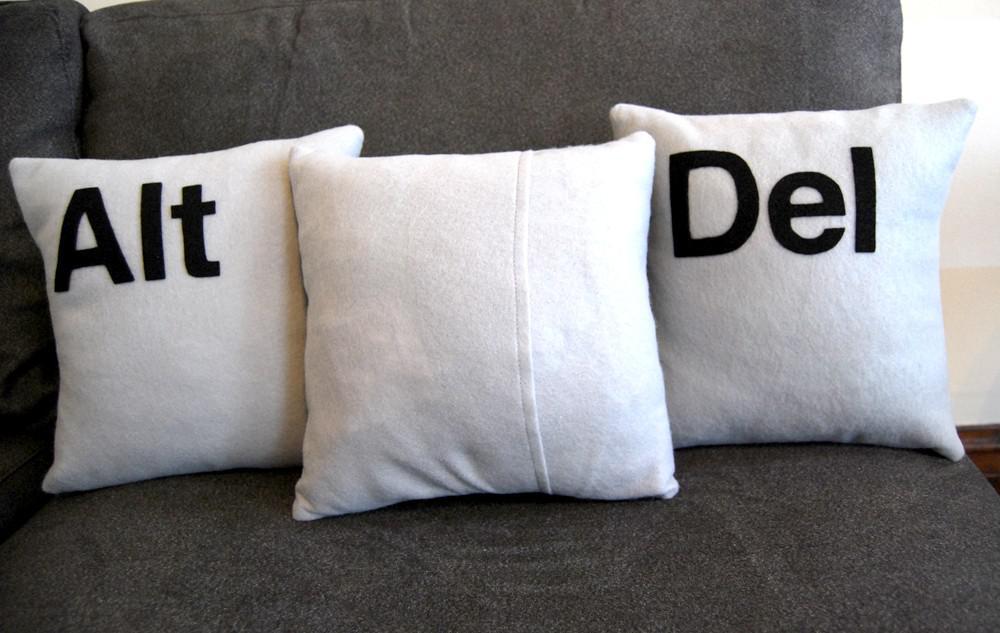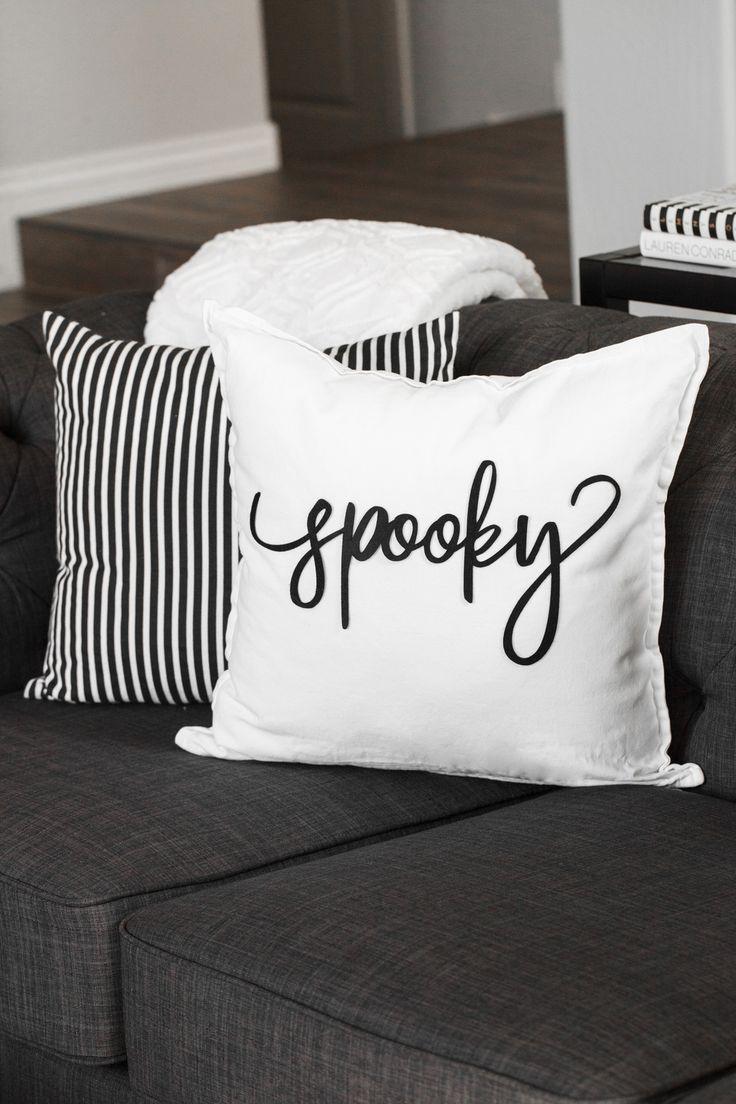The first image is the image on the left, the second image is the image on the right. For the images displayed, is the sentence "Every throw pillow pictured is square and whitish with at least one black letter on it, and each image contains exactly three throw pillows." factually correct? Answer yes or no. No. The first image is the image on the left, the second image is the image on the right. Examine the images to the left and right. Is the description "All of the pillows are computer related." accurate? Answer yes or no. No. 